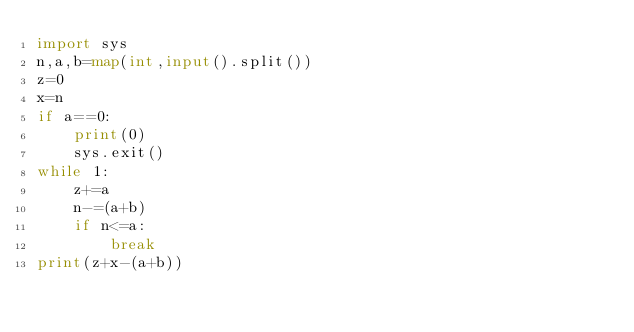<code> <loc_0><loc_0><loc_500><loc_500><_Python_>import sys
n,a,b=map(int,input().split())
z=0
x=n
if a==0:
    print(0)
    sys.exit()
while 1:
    z+=a
    n-=(a+b)
    if n<=a:
        break
print(z+x-(a+b))
    </code> 